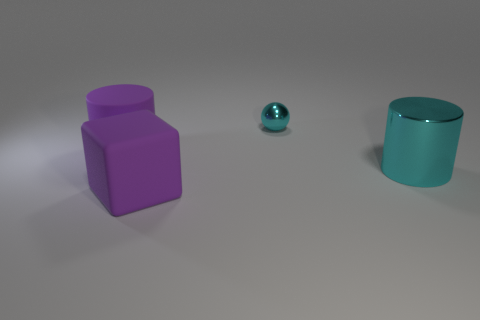Is there anything else that is the same size as the shiny ball?
Provide a succinct answer. No. Do the large purple block and the small cyan thing have the same material?
Offer a terse response. No. What number of other objects are the same material as the large purple cylinder?
Make the answer very short. 1. What number of objects are in front of the rubber cylinder and to the right of the cube?
Give a very brief answer. 1. What is the color of the ball?
Your response must be concise. Cyan. Does the large metallic cylinder have the same color as the ball?
Your answer should be compact. Yes. What is the shape of the large purple matte object that is to the left of the matte thing that is in front of the shiny cylinder?
Provide a succinct answer. Cylinder. What shape is the big thing that is the same material as the small ball?
Your answer should be compact. Cylinder. How many other objects are the same shape as the small thing?
Give a very brief answer. 0. There is a purple rubber cube to the left of the cyan cylinder; is it the same size as the small thing?
Your answer should be very brief. No. 